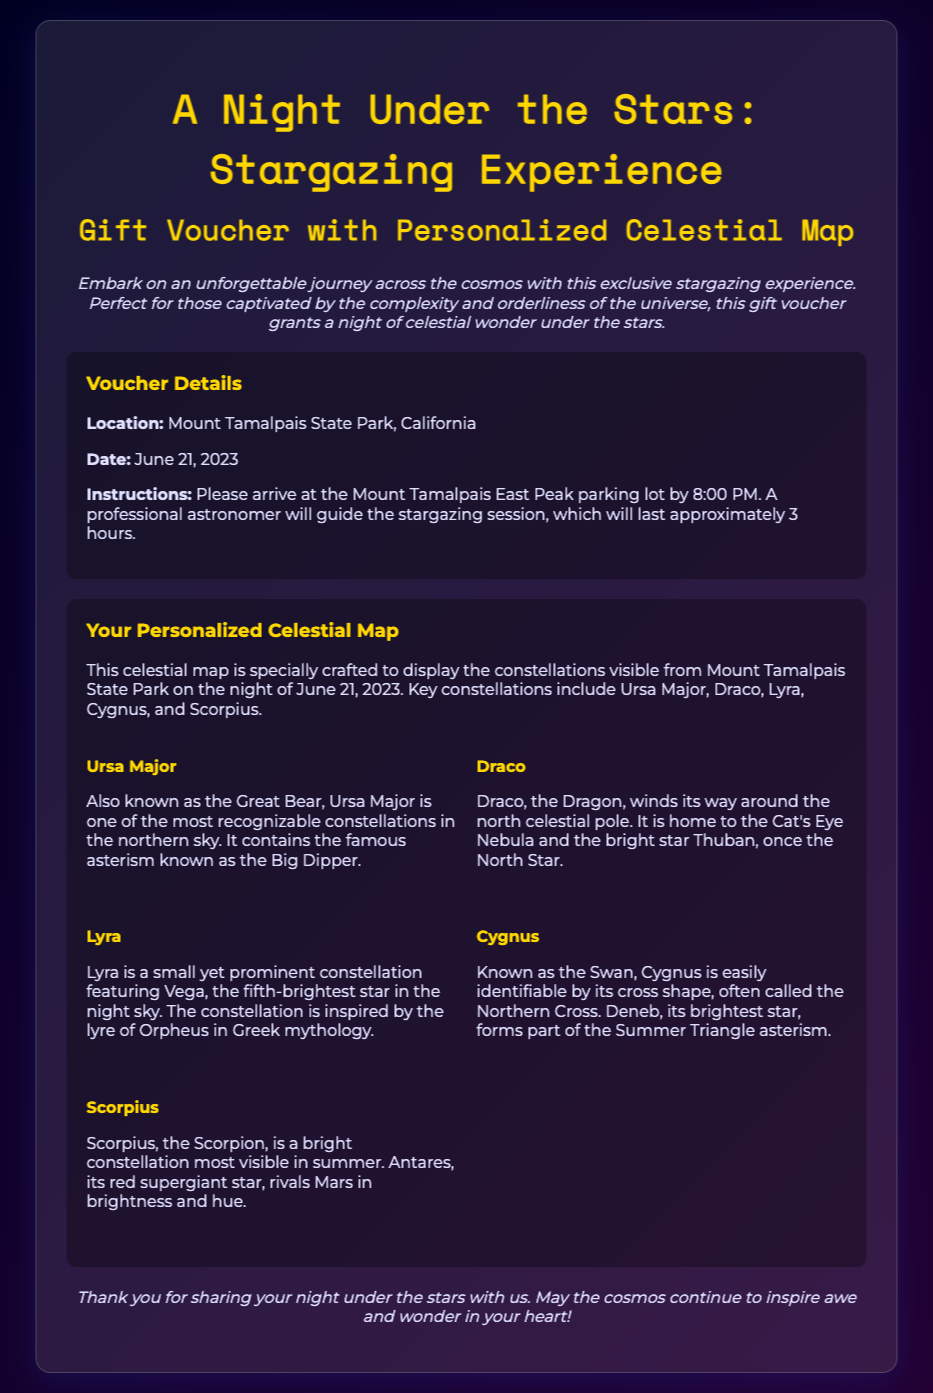What is the title of the experience? The title of the experience is presented prominently at the top of the document.
Answer: A Night Under the Stars: Stargazing Experience Where is the stargazing location? The location is given in the details section of the voucher.
Answer: Mount Tamalpais State Park, California What date is the stargazing experience scheduled for? The date is specified in the voucher details section.
Answer: June 21, 2023 What time should participants arrive at the location? The time is mentioned in the instructions provided in the document.
Answer: 8:00 PM Which constellation is known as the Great Bear? The document provides specific constellation names in the personalized celestial map section.
Answer: Ursa Major What is the brightest star in Lyra? The document contains information about the stars in each constellation.
Answer: Vega How long will the stargazing session last? The duration of the event is found in the instructions section of the document.
Answer: Approximately 3 hours What is the main theme of this voucher? The theme is reflected in the description, emphasizing an experience under the stars.
Answer: Celestial wonder Who will guide the stargazing session? The document states the type of professional assisting with the event.
Answer: A professional astronomer 